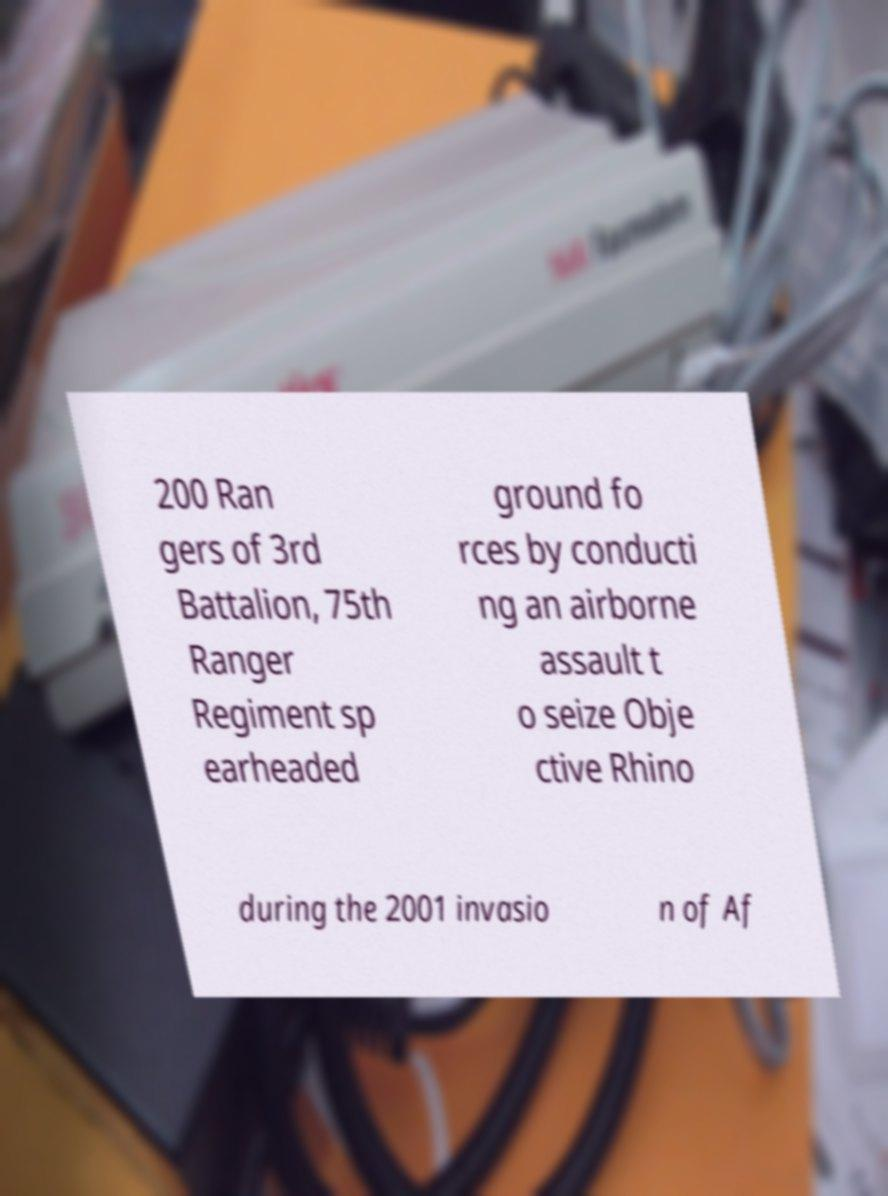Could you assist in decoding the text presented in this image and type it out clearly? 200 Ran gers of 3rd Battalion, 75th Ranger Regiment sp earheaded ground fo rces by conducti ng an airborne assault t o seize Obje ctive Rhino during the 2001 invasio n of Af 